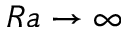<formula> <loc_0><loc_0><loc_500><loc_500>R a \rightarrow \infty</formula> 